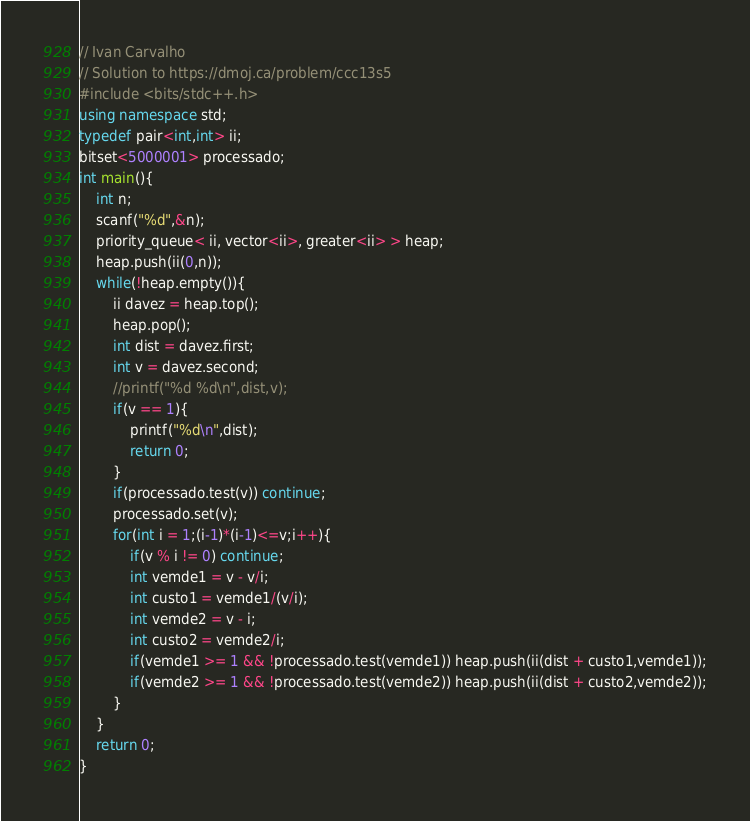Convert code to text. <code><loc_0><loc_0><loc_500><loc_500><_C++_>// Ivan Carvalho
// Solution to https://dmoj.ca/problem/ccc13s5
#include <bits/stdc++.h>
using namespace std;
typedef pair<int,int> ii;
bitset<5000001> processado;
int main(){
	int n;
	scanf("%d",&n);
	priority_queue< ii, vector<ii>, greater<ii> > heap;
	heap.push(ii(0,n));
	while(!heap.empty()){
		ii davez = heap.top();
		heap.pop();
		int dist = davez.first;
		int v = davez.second;
		//printf("%d %d\n",dist,v);
		if(v == 1){
			printf("%d\n",dist);
			return 0;
		}
		if(processado.test(v)) continue;
		processado.set(v);
		for(int i = 1;(i-1)*(i-1)<=v;i++){
			if(v % i != 0) continue;
			int vemde1 = v - v/i;
			int custo1 = vemde1/(v/i);
			int vemde2 = v - i;
			int custo2 = vemde2/i;
			if(vemde1 >= 1 && !processado.test(vemde1)) heap.push(ii(dist + custo1,vemde1));
			if(vemde2 >= 1 && !processado.test(vemde2)) heap.push(ii(dist + custo2,vemde2));
		}
	}
	return 0;
}</code> 